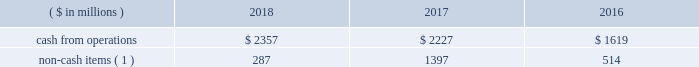We monitor the status of the capital markets and regularly evaluate the effect that changes in capital market conditions may have on our ability to execute our announced growth plans and fund our liquidity needs .
We expect to continue meeting part of our financing and liquidity needs primarily through commercial paper borrowings , issuances of senior notes , and access to long-term committed credit facilities .
If conditions in the lodging industry deteriorate , or if disruptions in the capital markets take place as they did in the immediate aftermath of both the 2008 worldwide financial crisis and the events of september 11 , 2001 , we may be unable to place some or all of our commercial paper on a temporary or extended basis and may have to rely more on borrowings under the credit facility , which we believe will be adequate to fund our liquidity needs , including repayment of debt obligations , but which may carry a higher cost than commercial paper .
Since we continue to have ample flexibility under the credit facility 2019s covenants , we expect that undrawn bank commitments under the credit facility will remain available to us even if business conditions were to deteriorate markedly .
Cash from operations cash from operations and non-cash items for the last three fiscal years are as follows: .
Non-cash items ( 1 ) 287 1397 514 ( 1 ) includes depreciation , amortization , share-based compensation , deferred income taxes , and contract investment amortization .
Our ratio of current assets to current liabilities was 0.4 to 1.0 at year-end 2018 and 0.5 to 1.0 at year-end 2017 .
We minimize working capital through cash management , strict credit-granting policies , and aggressive collection efforts .
We also have significant borrowing capacity under our credit facility should we need additional working capital .
Investing activities cash flows acquisition of a business , net of cash acquired .
Cash outflows of $ 2392 million in 2016 were due to the starwood combination .
See footnote 3 .
Dispositions and acquisitions for more information .
Capital expenditures and other investments .
We made capital expenditures of $ 556 million in 2018 , $ 240 million in 2017 , and $ 199 million in 2016 .
Capital expenditures in 2018 increased by $ 316 million compared to 2017 , primarily reflecting the acquisition of the sheraton grand phoenix , improvements to our worldwide systems , and net higher spending on several owned properties .
Capital expenditures in 2017 increased by $ 41 million compared to 2016 , primarily due to improvements to our worldwide systems and improvements to hotels acquired in the starwood combination .
We expect spending on capital expenditures and other investments will total approximately $ 500 million to $ 700 million for 2019 , including acquisitions , loan advances , equity and other investments , contract acquisition costs , and various capital expenditures ( including approximately $ 225 million for maintenance capital spending ) .
Over time , we have sold lodging properties , both completed and under development , subject to long-term management agreements .
The ability of third-party purchasers to raise the debt and equity capital necessary to acquire such properties depends in part on the perceived risks in the lodging industry and other constraints inherent in the capital markets .
We monitor the status of the capital markets and regularly evaluate the potential impact of changes in capital market conditions on our business operations .
In the starwood combination , we acquired various hotels and joint venture interests in hotels , most of which we have sold or are seeking to sell , and in 2018 , we acquired the sheraton grand phoenix , which we expect to renovate and sell subject to a long-term management agreement .
We also expect to continue making selective and opportunistic investments to add units to our lodging business , which may include property acquisitions , new construction , loans , guarantees , and noncontrolling equity investments .
Over time , we seek to minimize capital invested in our business through asset sales subject to long term operating or franchise agreements .
Fluctuations in the values of hotel real estate generally have little impact on our overall business results because : ( 1 ) we own less than one percent of hotels that we operate or franchise ; ( 2 ) management and franchise fees are generally based upon hotel revenues and profits rather than current hotel property values ; and ( 3 ) our management agreements generally do not terminate upon hotel sale or foreclosure .
Dispositions .
Property and asset sales generated $ 479 million cash proceeds in 2018 and $ 1418 million in 2017 .
See footnote 3 .
Dispositions and acquisitions for more information on dispositions. .
Non cash items represent what percent of cash from operations in 2017? 
Computations: (1397 / 2227)
Answer: 0.6273. 